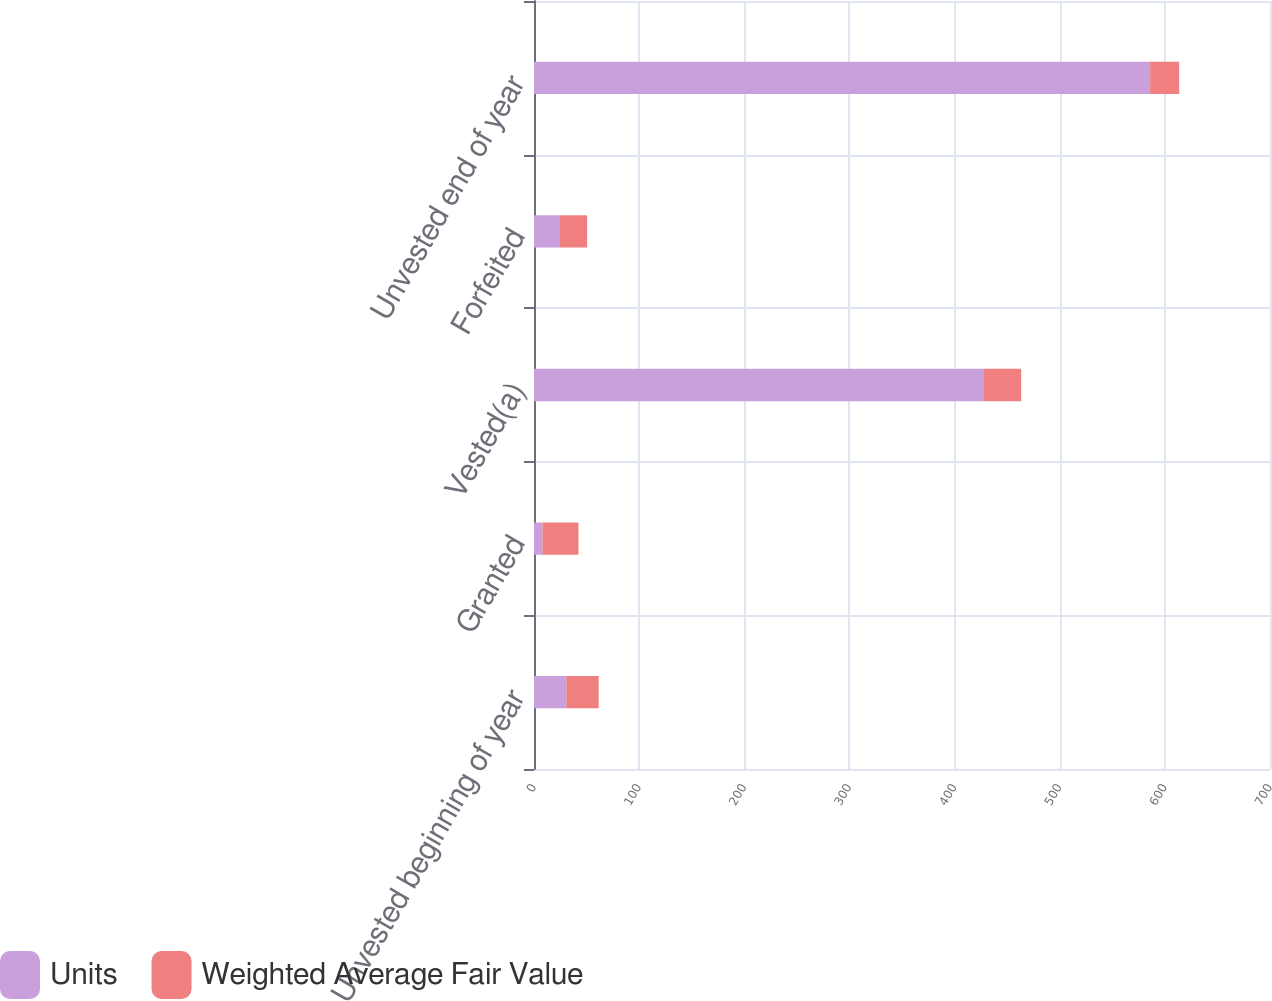Convert chart to OTSL. <chart><loc_0><loc_0><loc_500><loc_500><stacked_bar_chart><ecel><fcel>Unvested beginning of year<fcel>Granted<fcel>Vested(a)<fcel>Forfeited<fcel>Unvested end of year<nl><fcel>Units<fcel>30.76<fcel>8<fcel>428<fcel>24<fcel>586<nl><fcel>Weighted Average Fair Value<fcel>30.76<fcel>34.25<fcel>35.37<fcel>26.54<fcel>27.61<nl></chart> 